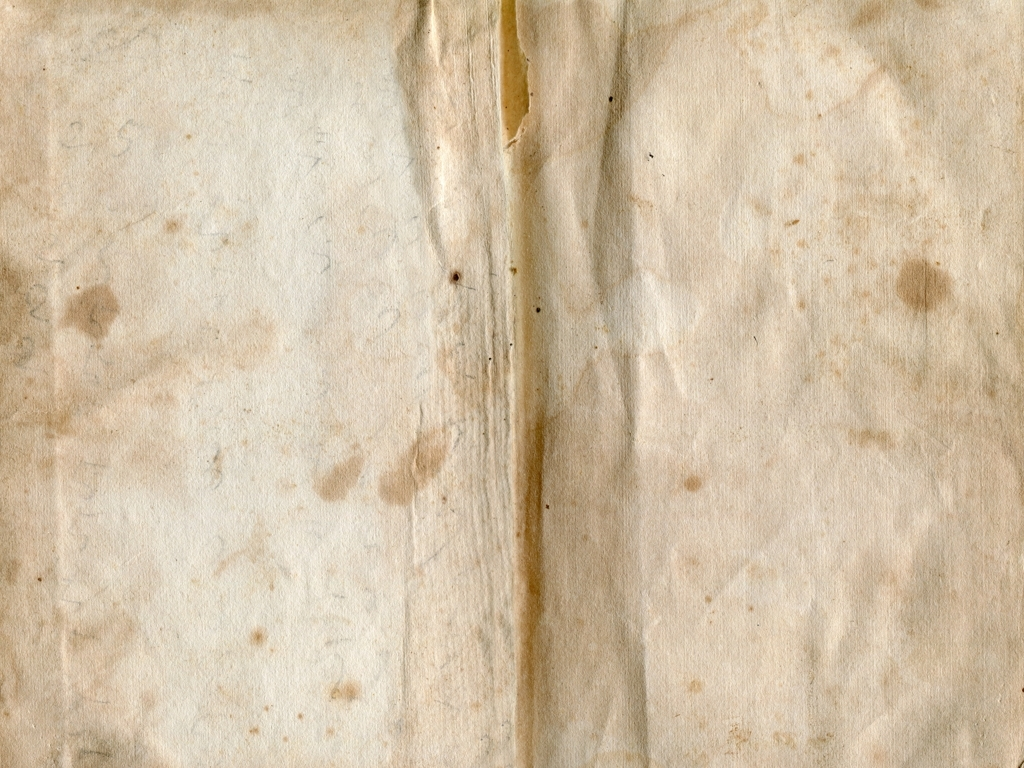What type of use could this piece of paper have had? The paper could have had numerous uses; it might have been part of a personal journal, an official document, or simply a sheet for everyday note-taking. The wear and stains suggest it was frequently handled or stored in less than ideal conditions. 